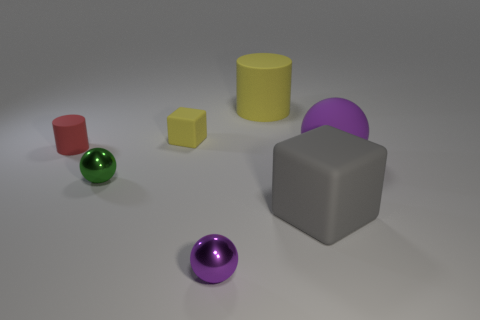What is the shape of the object that is the same color as the big cylinder?
Provide a short and direct response. Cube. Are there any other yellow matte things of the same shape as the tiny yellow thing?
Provide a succinct answer. No. Is the number of tiny red things left of the small red matte thing less than the number of green shiny objects behind the small green ball?
Your answer should be compact. No. What is the color of the small matte block?
Provide a succinct answer. Yellow. There is a purple ball that is right of the gray cube; is there a tiny red rubber cylinder that is in front of it?
Ensure brevity in your answer.  No. What number of cyan metallic cylinders have the same size as the red rubber object?
Your answer should be very brief. 0. There is a yellow matte cylinder behind the purple thing on the left side of the gray rubber object; what number of big matte objects are right of it?
Your response must be concise. 2. What number of things are both left of the matte sphere and behind the large matte cube?
Keep it short and to the point. 4. Is there anything else that is the same color as the large rubber cylinder?
Offer a very short reply. Yes. What number of matte things are either blocks or small red things?
Make the answer very short. 3. 